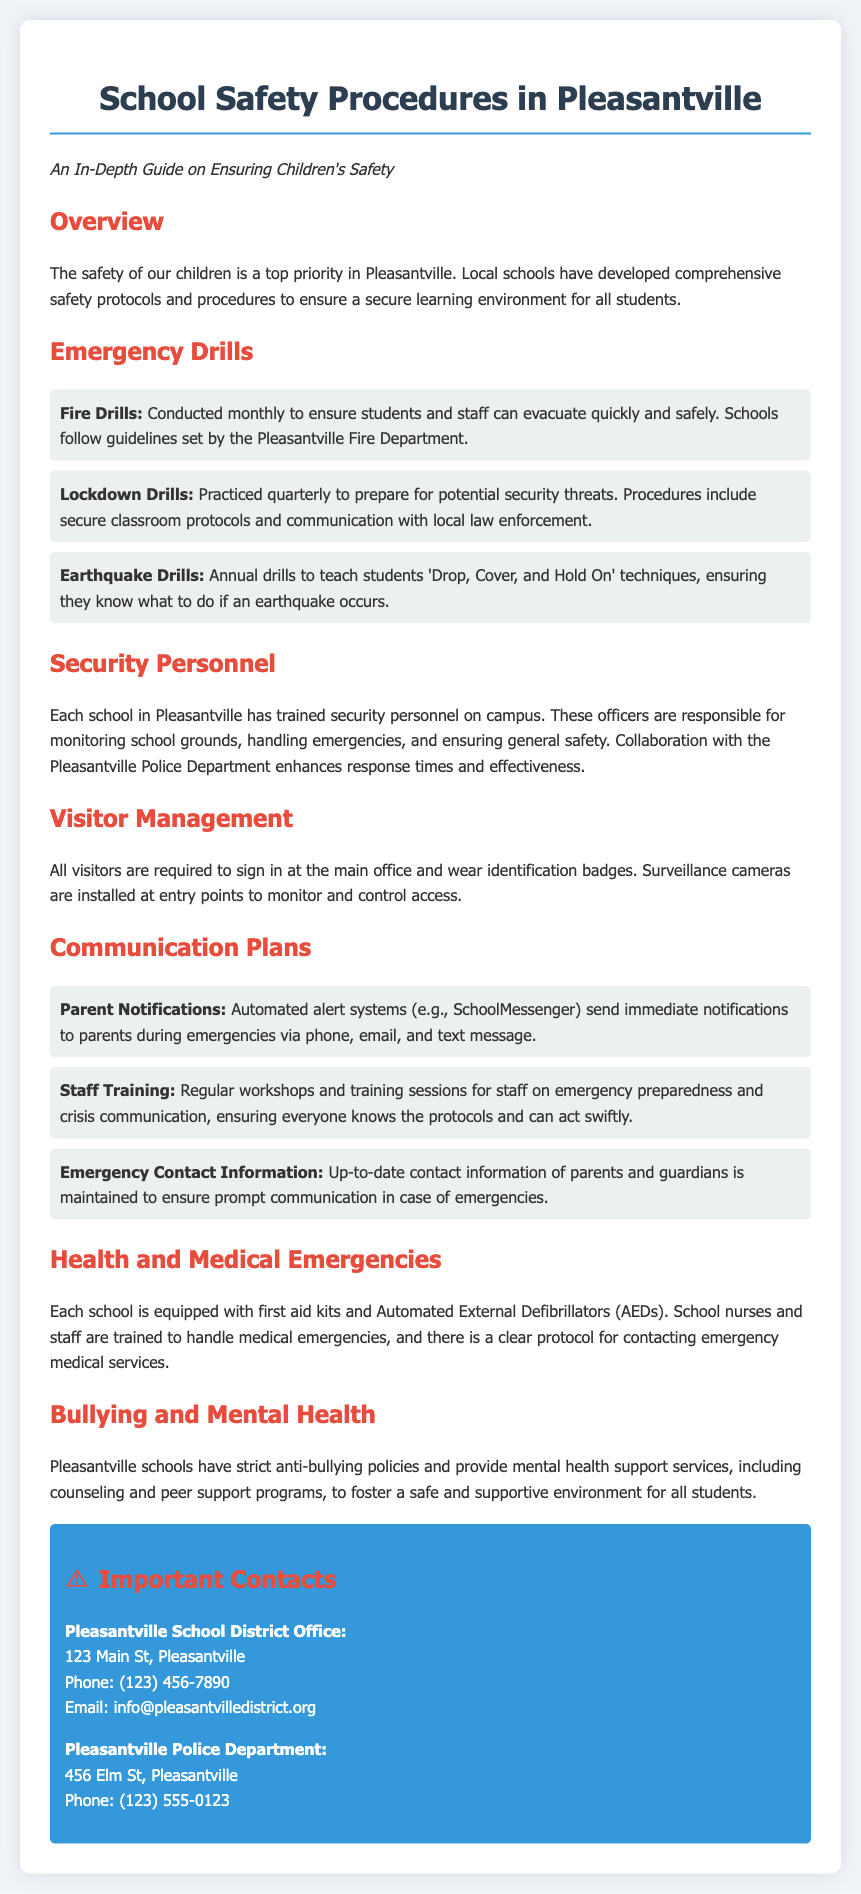what type of drills are practiced monthly? Fire drills are conducted monthly to ensure students and staff can evacuate quickly and safely.
Answer: Fire drills how often are lockdown drills practiced? Lockdown drills are practiced quarterly to prepare for potential security threats.
Answer: Quarterly who collaborates with security personnel at schools? The Pleasantville Police Department collaborates with the security personnel to enhance response times and effectiveness.
Answer: Pleasantville Police Department what system is used for parent notifications during emergencies? Automated alert systems like SchoolMessenger send immediate notifications to parents during emergencies.
Answer: SchoolMessenger what is the address of the Pleasantville School District Office? The address of the Pleasantville School District Office is 123 Main St, Pleasantville.
Answer: 123 Main St, Pleasantville how many types of emergency drills are mentioned in the document? The document mentions three types of emergency drills: fire drills, lockdown drills, and earthquake drills.
Answer: Three what protocol is followed for health and medical emergencies? Each school has a clear protocol for contacting emergency medical services in case of health and medical emergencies.
Answer: Protocol for contacting emergency medical services what is the purpose of visitor management in schools? Visitor management ensures that all visitors sign in and wear identification badges to monitor and control access.
Answer: Monitor and control access what support services are provided for mental health? Pleasantville schools provide counseling and peer support programs for mental health support.
Answer: Counseling and peer support programs 